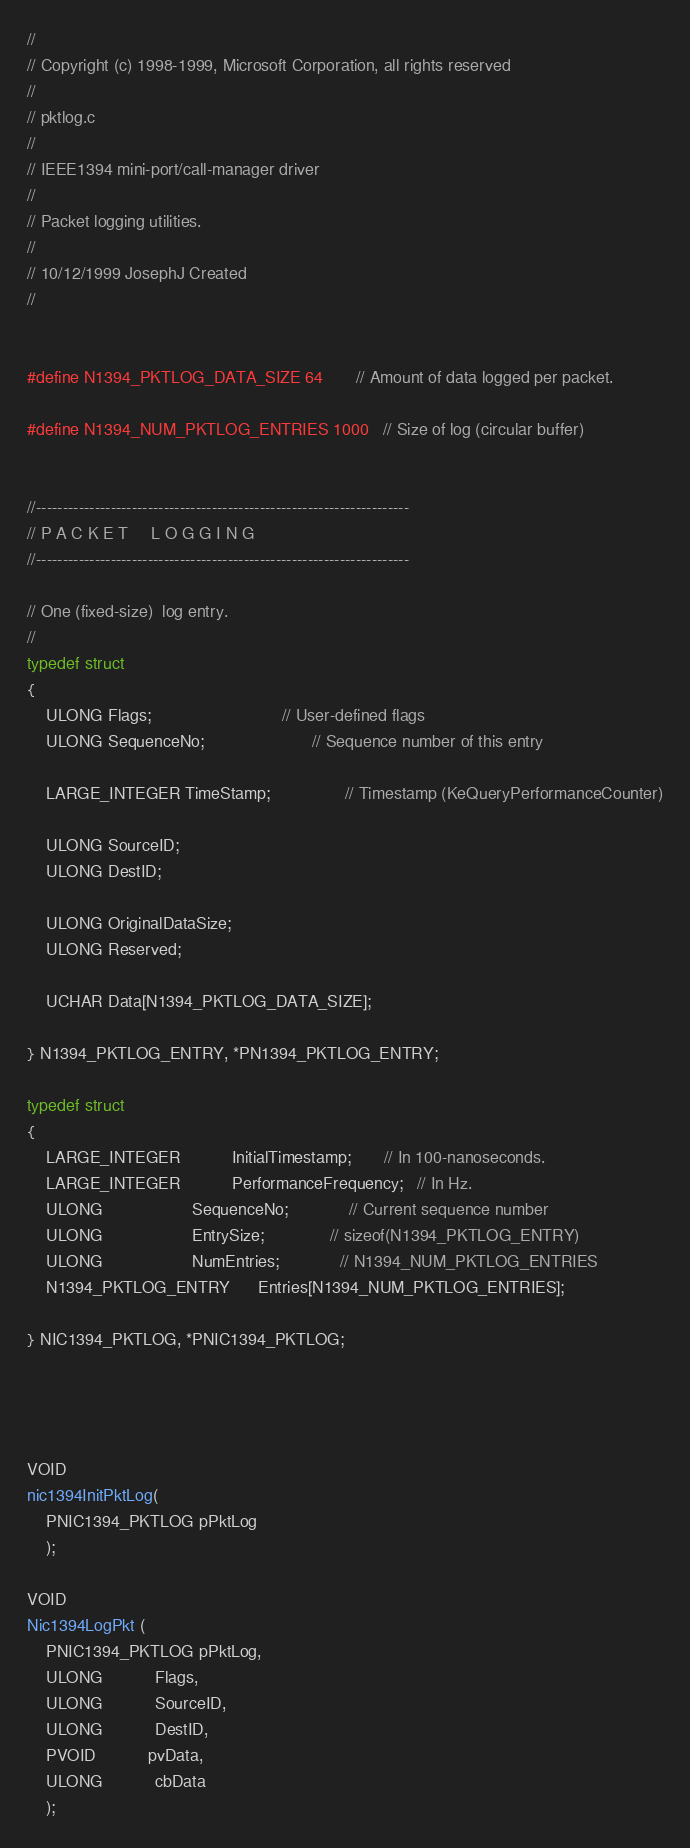<code> <loc_0><loc_0><loc_500><loc_500><_C_>//
// Copyright (c) 1998-1999, Microsoft Corporation, all rights reserved
//
// pktlog.c
//
// IEEE1394 mini-port/call-manager driver
//
// Packet logging utilities.
//
// 10/12/1999 JosephJ Created
//
    

#define N1394_PKTLOG_DATA_SIZE 64       // Amount of data logged per packet.

#define N1394_NUM_PKTLOG_ENTRIES 1000   // Size of log (circular buffer)


//----------------------------------------------------------------------
// P A C K E T     L O G G I N G
//----------------------------------------------------------------------

// One (fixed-size)  log entry.
//
typedef struct
{
    ULONG Flags;                            // User-defined flags
    ULONG SequenceNo;                       // Sequence number of this entry

    LARGE_INTEGER TimeStamp;                // Timestamp (KeQueryPerformanceCounter)

    ULONG SourceID;
    ULONG DestID;

    ULONG OriginalDataSize;
    ULONG Reserved;

    UCHAR Data[N1394_PKTLOG_DATA_SIZE];

} N1394_PKTLOG_ENTRY, *PN1394_PKTLOG_ENTRY;

typedef struct
{
    LARGE_INTEGER           InitialTimestamp;       // In 100-nanoseconds.
    LARGE_INTEGER           PerformanceFrequency;   // In Hz.
    ULONG                   SequenceNo;             // Current sequence number
    ULONG                   EntrySize;              // sizeof(N1394_PKTLOG_ENTRY)
    ULONG                   NumEntries;             // N1394_NUM_PKTLOG_ENTRIES
    N1394_PKTLOG_ENTRY      Entries[N1394_NUM_PKTLOG_ENTRIES];
    
} NIC1394_PKTLOG, *PNIC1394_PKTLOG;


    

VOID
nic1394InitPktLog(
    PNIC1394_PKTLOG pPktLog
    );

VOID
Nic1394LogPkt (
    PNIC1394_PKTLOG pPktLog,
    ULONG           Flags,
    ULONG           SourceID,
    ULONG           DestID,
    PVOID           pvData,
    ULONG           cbData
    );

</code> 